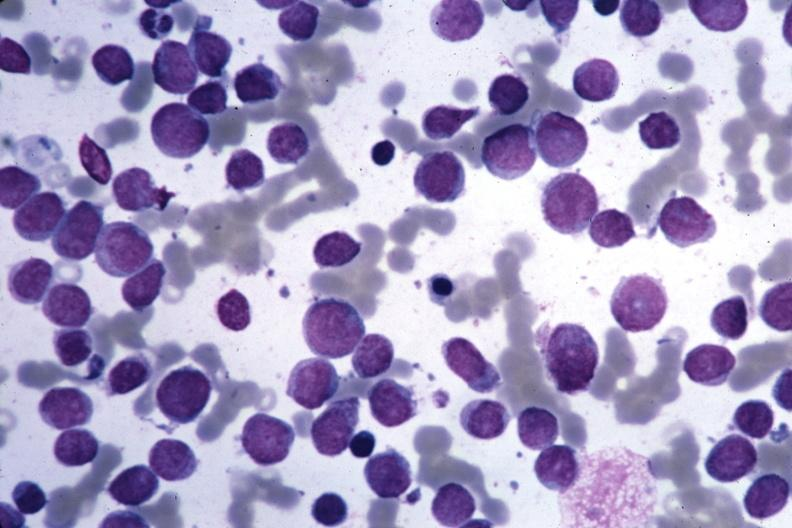what is present?
Answer the question using a single word or phrase. Hematologic 